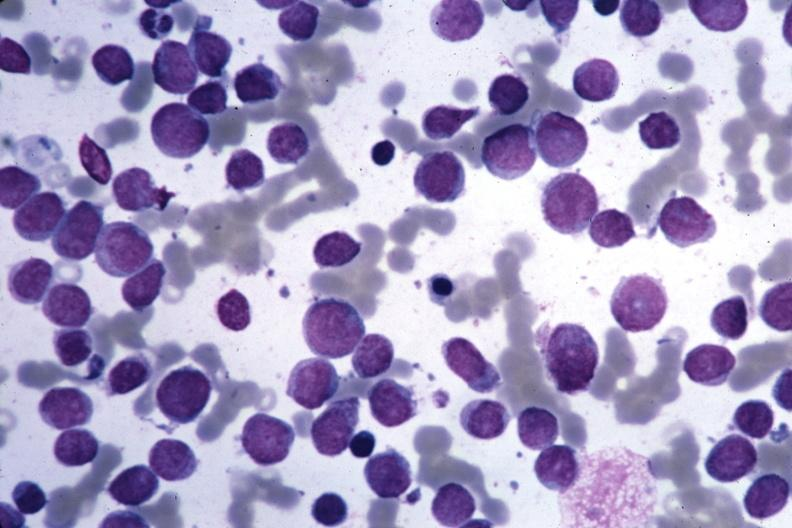what is present?
Answer the question using a single word or phrase. Hematologic 